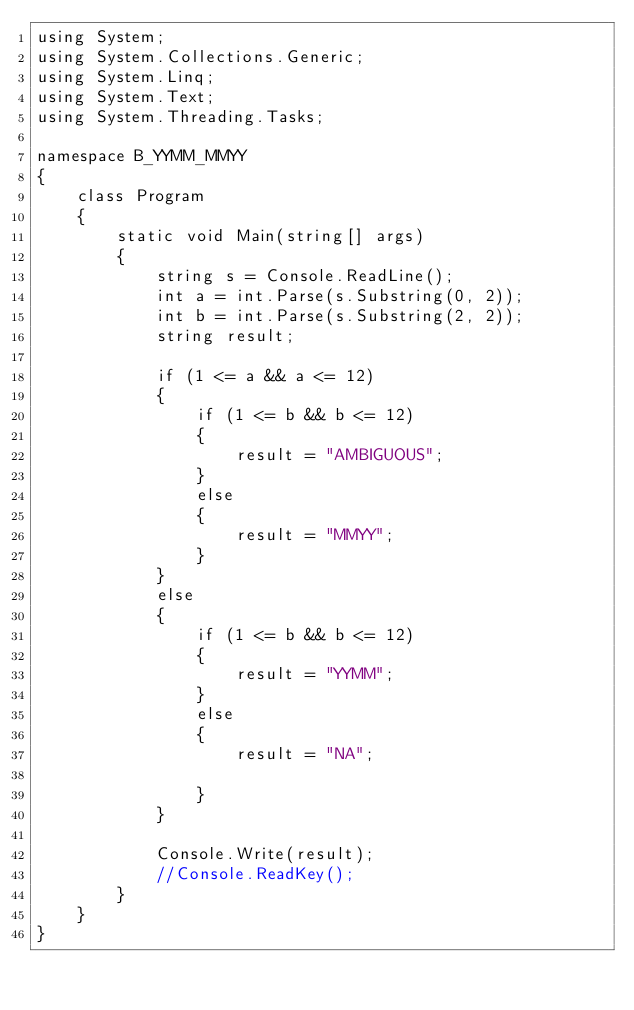Convert code to text. <code><loc_0><loc_0><loc_500><loc_500><_C#_>using System;
using System.Collections.Generic;
using System.Linq;
using System.Text;
using System.Threading.Tasks;

namespace B_YYMM_MMYY
{
    class Program
    {
        static void Main(string[] args)
        {
            string s = Console.ReadLine();
            int a = int.Parse(s.Substring(0, 2));
            int b = int.Parse(s.Substring(2, 2));
            string result;

            if (1 <= a && a <= 12)
            {
                if (1 <= b && b <= 12)
                {
                    result = "AMBIGUOUS";
                }
                else
                {
                    result = "MMYY";
                }
            }
            else
            {
                if (1 <= b && b <= 12)
                {
                    result = "YYMM";
                }
                else
                {
                    result = "NA";

                }
            }

            Console.Write(result);
            //Console.ReadKey();
        }
    }
}
</code> 